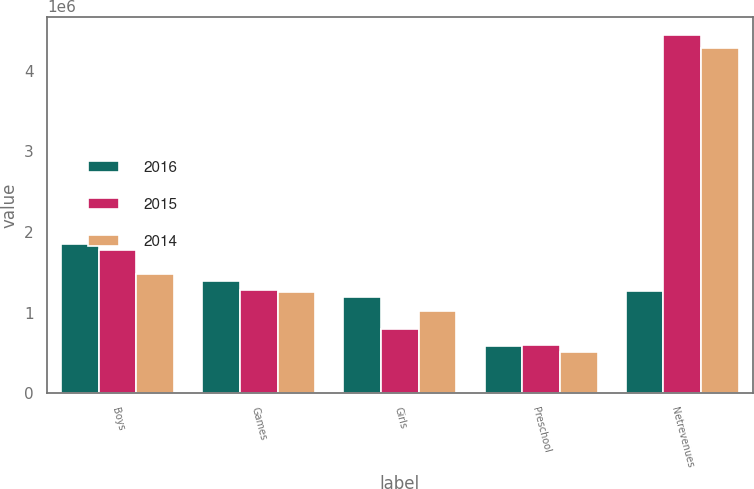Convert chart. <chart><loc_0><loc_0><loc_500><loc_500><stacked_bar_chart><ecel><fcel>Boys<fcel>Games<fcel>Girls<fcel>Preschool<fcel>Netrevenues<nl><fcel>2016<fcel>1.84964e+06<fcel>1.38708e+06<fcel>1.19388e+06<fcel>589223<fcel>1.26816e+06<nl><fcel>2015<fcel>1.77592e+06<fcel>1.27653e+06<fcel>798240<fcel>596820<fcel>4.44751e+06<nl><fcel>2014<fcel>1.48395e+06<fcel>1.25978e+06<fcel>1.02263e+06<fcel>510840<fcel>4.27721e+06<nl></chart> 